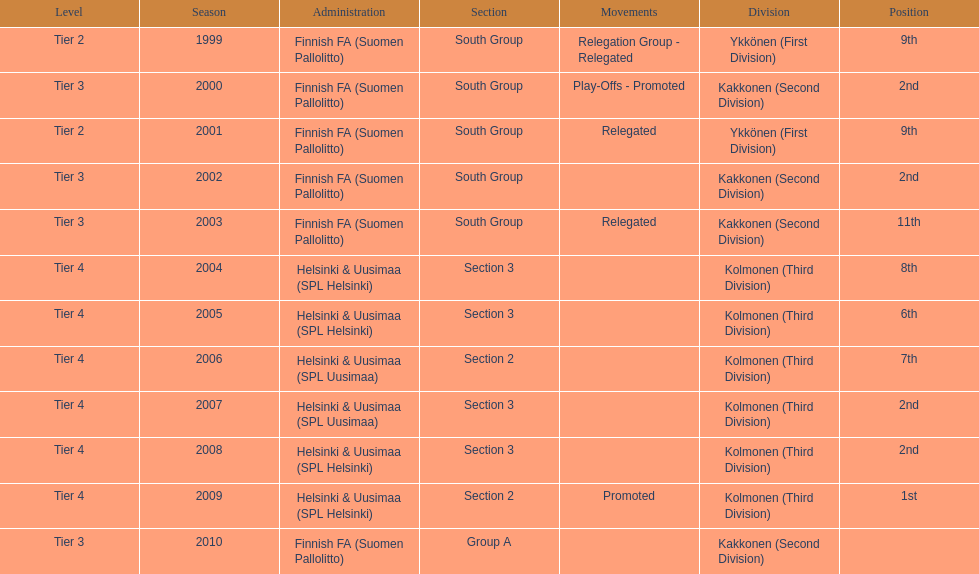What division were they in the most, section 3 or 2? 3. 